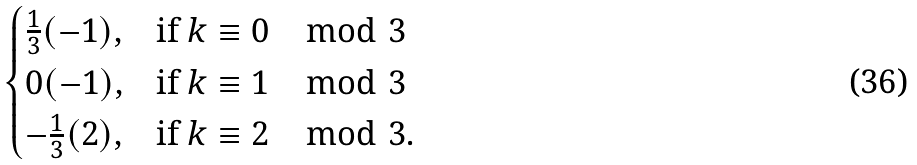<formula> <loc_0><loc_0><loc_500><loc_500>\begin{cases} \frac { 1 } { 3 } ( - 1 ) , & \text {if $k\equiv 0\mod{3}$} \\ 0 ( - 1 ) , & \text {if $k\equiv 1\mod{3}$} \\ - \frac { 1 } { 3 } ( 2 ) , & \text {if $k\equiv 2\mod{3}$.} \end{cases}</formula> 